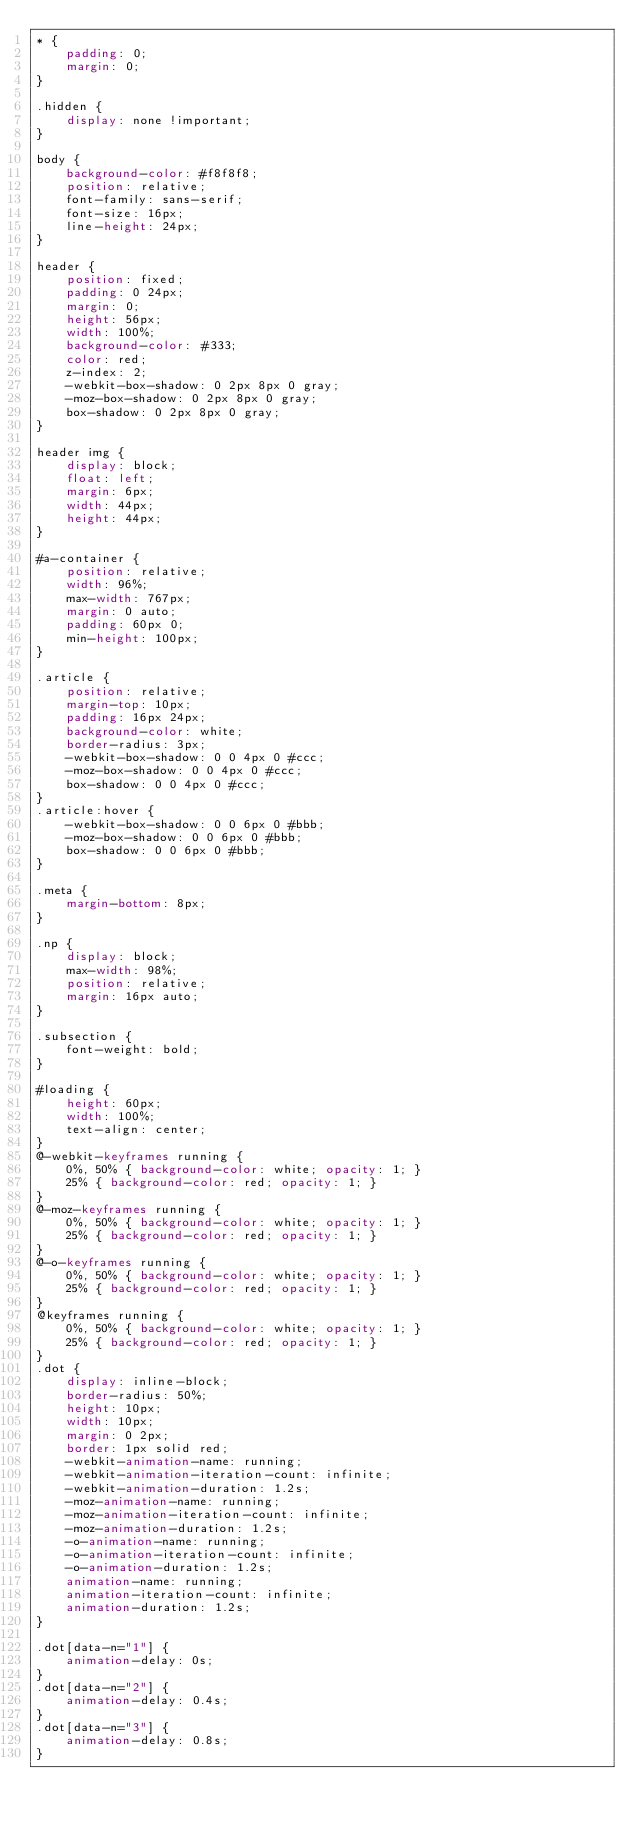<code> <loc_0><loc_0><loc_500><loc_500><_CSS_>* {
    padding: 0;
    margin: 0;
}

.hidden {
    display: none !important;
}

body {
    background-color: #f8f8f8;
    position: relative;
    font-family: sans-serif;
    font-size: 16px;
    line-height: 24px;
}

header {
    position: fixed;
    padding: 0 24px;
    margin: 0;
    height: 56px;
    width: 100%;
    background-color: #333;
    color: red;
    z-index: 2;
    -webkit-box-shadow: 0 2px 8px 0 gray; 
    -moz-box-shadow: 0 2px 8px 0 gray;
    box-shadow: 0 2px 8px 0 gray;
}

header img {
    display: block;
    float: left;
    margin: 6px;
    width: 44px;
    height: 44px;
}

#a-container {
    position: relative;
    width: 96%;
    max-width: 767px;
    margin: 0 auto;
    padding: 60px 0;
    min-height: 100px;
}

.article {
    position: relative;
    margin-top: 10px;
    padding: 16px 24px;
    background-color: white;
    border-radius: 3px;
    -webkit-box-shadow: 0 0 4px 0 #ccc; 
    -moz-box-shadow: 0 0 4px 0 #ccc;
    box-shadow: 0 0 4px 0 #ccc;
}
.article:hover {
    -webkit-box-shadow: 0 0 6px 0 #bbb; 
    -moz-box-shadow: 0 0 6px 0 #bbb;
    box-shadow: 0 0 6px 0 #bbb;    
}

.meta {
    margin-bottom: 8px;
}

.np {
    display: block;
    max-width: 98%;
    position: relative;
    margin: 16px auto;
}

.subsection {
    font-weight: bold;
}

#loading {
    height: 60px;
    width: 100%;
    text-align: center;
}
@-webkit-keyframes running {  
    0%, 50% { background-color: white; opacity: 1; }
    25% { background-color: red; opacity: 1; }
}
@-moz-keyframes running {  
    0%, 50% { background-color: white; opacity: 1; }
    25% { background-color: red; opacity: 1; }
}
@-o-keyframes running {  
    0%, 50% { background-color: white; opacity: 1; }
    25% { background-color: red; opacity: 1; }
}
@keyframes running {  
    0%, 50% { background-color: white; opacity: 1; }
    25% { background-color: red; opacity: 1; }
}
.dot {
    display: inline-block;
    border-radius: 50%;
    height: 10px;
    width: 10px;
    margin: 0 2px;
    border: 1px solid red;
    -webkit-animation-name: running;
    -webkit-animation-iteration-count: infinite;  
    -webkit-animation-duration: 1.2s; 
    -moz-animation-name: running;
    -moz-animation-iteration-count: infinite;  
    -moz-animation-duration: 1.2s; 
    -o-animation-name: running;
    -o-animation-iteration-count: infinite;  
    -o-animation-duration: 1.2s; 
    animation-name: running;
    animation-iteration-count: infinite;  
    animation-duration: 1.2s;
}

.dot[data-n="1"] {
    animation-delay: 0s;
}
.dot[data-n="2"] {
    animation-delay: 0.4s;
}
.dot[data-n="3"] {
    animation-delay: 0.8s;
}</code> 